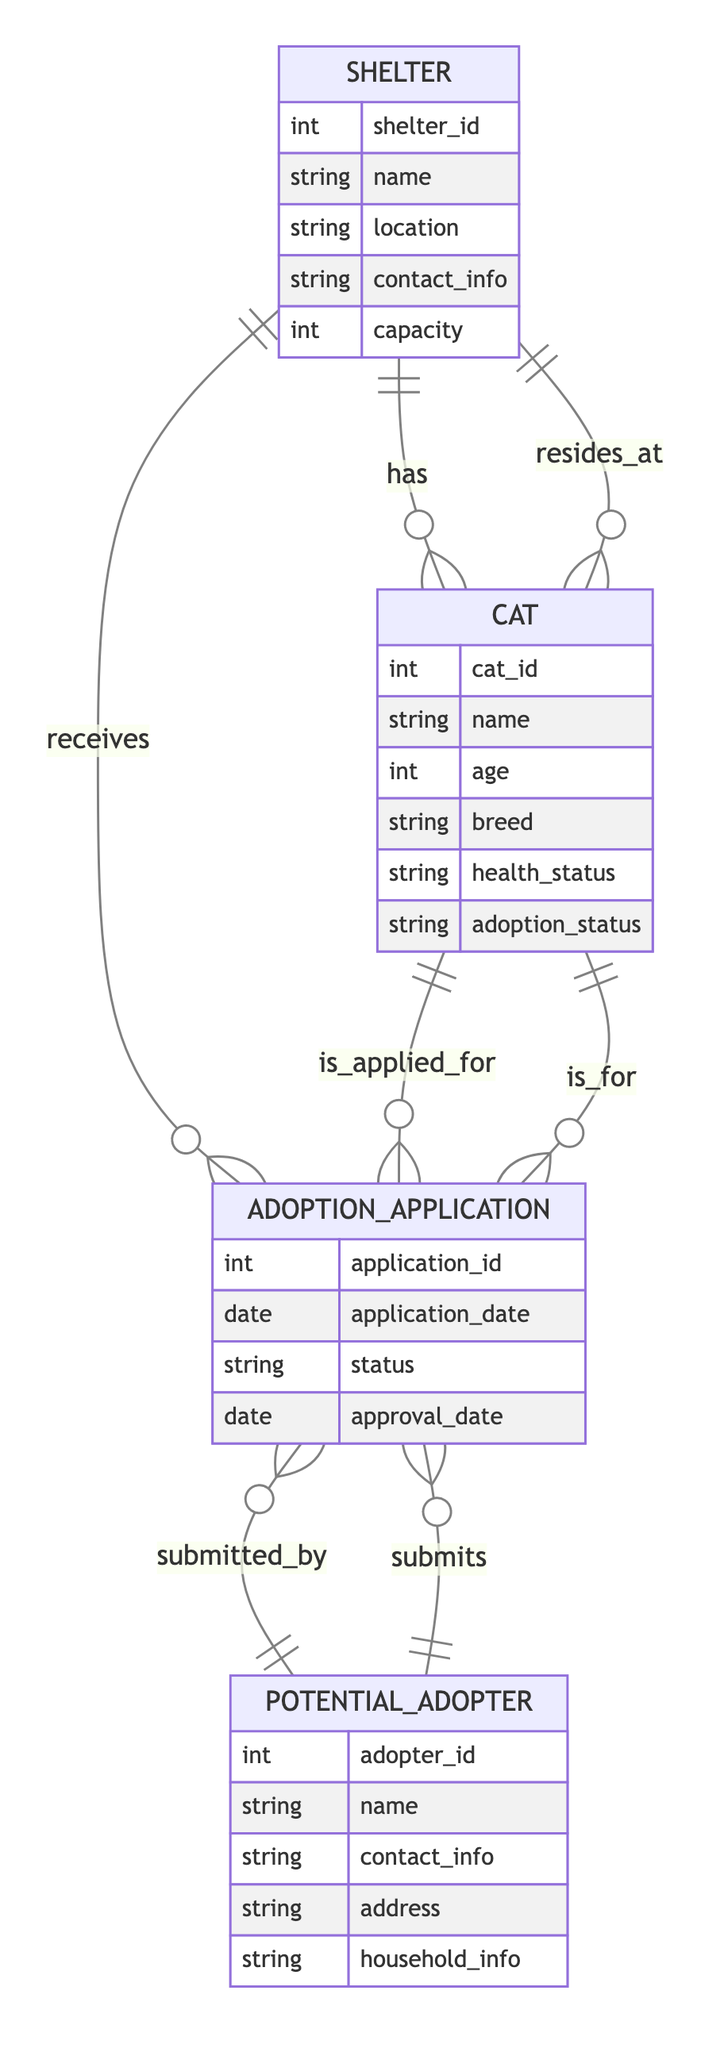What is the maximum number of cats that a shelter can have? The capacity attribute of the Shelter entity indicates the maximum number of cats that can be housed. The diagram specifies this attribute under the Shelter entity.
Answer: capacity How many entities are involved in the adoption process? The diagram features four entities: Shelter, Cat, Adoption Application, and Potential Adopter. By counting each unique entity, we determine the total number of entities described.
Answer: 4 What relationship connects a Potential Adopter to an Adoption Application? The connection is indicated as 'submits', which shows that a Potential Adopter is associated with submitting an Adoption Application. This is shown in the relationships section of the Potential Adopter entity.
Answer: submits How many cats can be associated with one Adoption Application? The relationship 'is_applied_for' specifies that one Adoption Application can apply for many cats, thus one can be related to multiple cats based on this relationship.
Answer: many What type of entity is 'Adoption Application'? The 'Adoption Application' is a central entity concerning the application's status, date, and affiliation with both the Cat being adopted and the Potential Adopter submitting it. This can be confirmed through the attributes listed in the Adoption Application entity.
Answer: central entity Which entities are directly linked to the Shelter entity? The Shelter entity directly links to two other entities: Cat (through the 'has' relationship) and Adoption Application (through the 'receives' relationship). This means each shelter can have zero or more cats and also receive multiple adoption applications.
Answer: Cat, Adoption Application What indicates the health status of a cat? The health status of a cat is defined as an attribute in the Cat entity. This attribute provides critical information regarding each cat’s health which is essential for potential adopters to know.
Answer: health_status Can one Potential Adopter submit multiple Adoption Applications? Yes, the relationship 'submits' shows that one Potential Adopter can submit multiple Adoption Applications, indicating a one-to-many relationship between Potential Adopter and Adoption Application.
Answer: yes What is the main relationship between Cat and Shelter? The main relationship is indicated as 'resides_at', meaning each cat stays at one shelter. This highlights the fact that many cats can be sheltered at a single location.
Answer: resides_at 